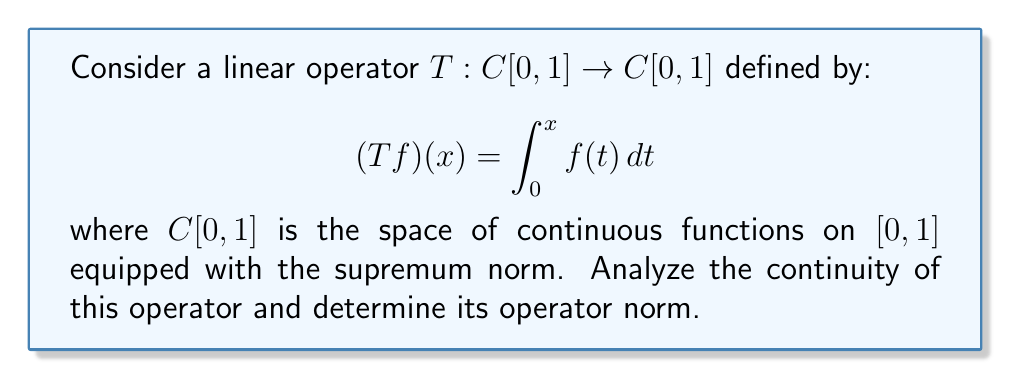What is the answer to this math problem? Let's approach this step-by-step:

1) First, we need to verify if $T$ is indeed a linear operator:
   For any $f, g \in C[0,1]$ and scalar $\alpha$:
   $T(\alpha f + g)(x) = \int_0^x (\alpha f(t) + g(t)) dt = \alpha \int_0^x f(t) dt + \int_0^x g(t) dt = \alpha (Tf)(x) + (Tg)(x)$
   This confirms that $T$ is linear.

2) To analyze continuity, we'll show that $T$ is bounded:
   For any $f \in C[0,1]$:
   $|(Tf)(x)| = |\int_0^x f(t) dt| \leq \int_0^x |f(t)| dt \leq \int_0^x \|f\|_\infty dt = x\|f\|_\infty \leq \|f\|_\infty$

   Therefore, $\|Tf\|_\infty \leq \|f\|_\infty$

3) This implies that $T$ is bounded with $\|T\| \leq 1$, and thus continuous.

4) To find the exact operator norm, we need to show that $\|T\| = 1$:
   Consider the sequence of functions $f_n(x) = x^n$. We have:
   $(Tf_n)(x) = \int_0^x t^n dt = \frac{x^{n+1}}{n+1}$

   $\|f_n\|_\infty = 1$ (achieved at $x=1$)
   $\|Tf_n\|_\infty = \frac{1}{n+1}$ (also achieved at $x=1$)

   $\frac{\|Tf_n\|_\infty}{\|f_n\|_\infty} = \frac{1}{n+1} \rightarrow 1$ as $n \rightarrow \infty$

5) This shows that the operator norm of $T$ is exactly 1.
Answer: $T$ is continuous with operator norm $\|T\| = 1$. 